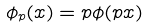<formula> <loc_0><loc_0><loc_500><loc_500>\phi _ { p } ( x ) = p \phi ( p x )</formula> 